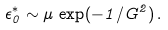Convert formula to latex. <formula><loc_0><loc_0><loc_500><loc_500>\epsilon _ { 0 } ^ { * } \sim \mu \, \exp ( - 1 / G ^ { 2 } ) \, .</formula> 